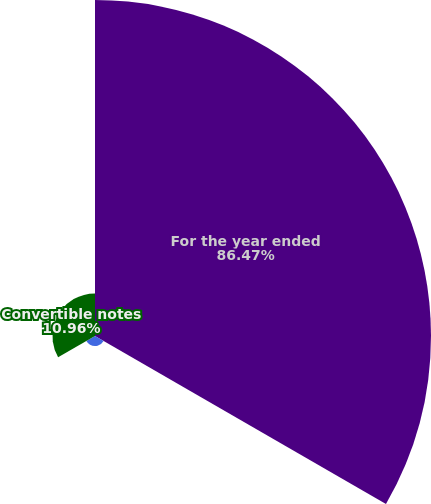<chart> <loc_0><loc_0><loc_500><loc_500><pie_chart><fcel>For the year ended<fcel>Equity plans<fcel>Convertible notes<nl><fcel>86.46%<fcel>2.57%<fcel>10.96%<nl></chart> 